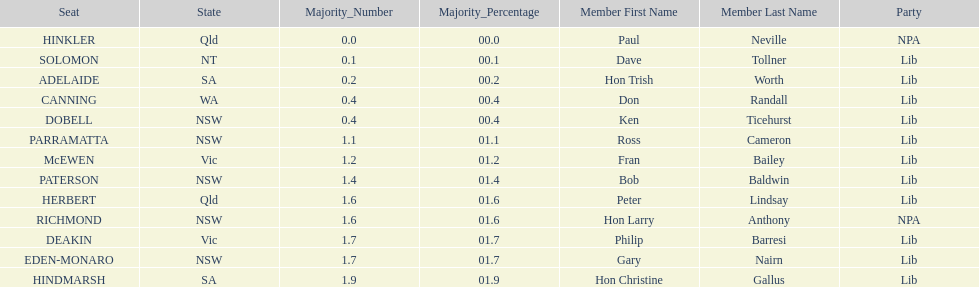Who is listed before don randall? Hon Trish Worth. 